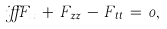<formula> <loc_0><loc_0><loc_500><loc_500>\, i \alpha F _ { x } \, + \, F _ { z z } \, - \, F _ { t t } \, = \, 0 ,</formula> 